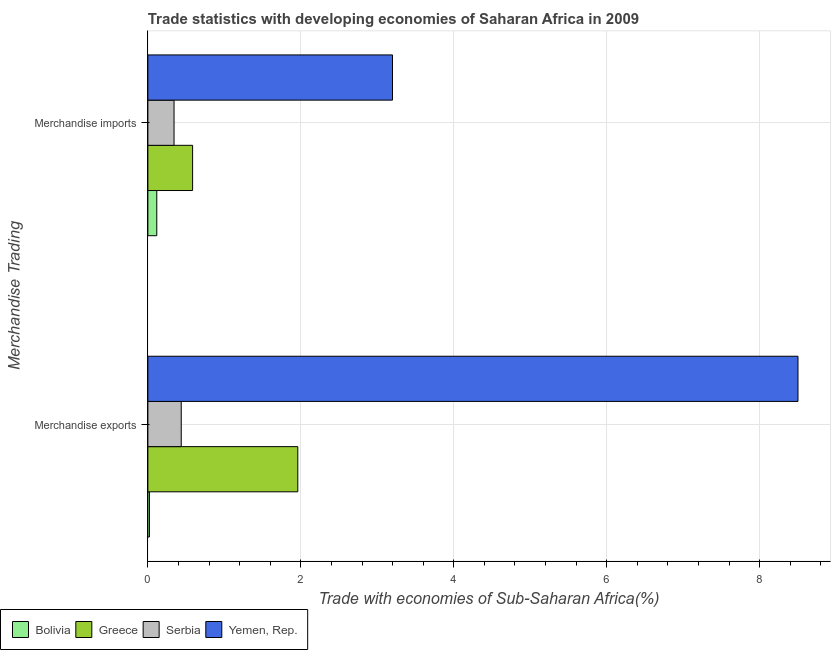How many different coloured bars are there?
Make the answer very short. 4. How many groups of bars are there?
Offer a very short reply. 2. Are the number of bars on each tick of the Y-axis equal?
Make the answer very short. Yes. What is the merchandise exports in Yemen, Rep.?
Provide a short and direct response. 8.5. Across all countries, what is the maximum merchandise imports?
Your answer should be compact. 3.2. Across all countries, what is the minimum merchandise exports?
Provide a succinct answer. 0.02. In which country was the merchandise imports maximum?
Your response must be concise. Yemen, Rep. In which country was the merchandise exports minimum?
Give a very brief answer. Bolivia. What is the total merchandise imports in the graph?
Offer a very short reply. 4.24. What is the difference between the merchandise exports in Greece and that in Bolivia?
Offer a very short reply. 1.94. What is the difference between the merchandise imports in Serbia and the merchandise exports in Bolivia?
Offer a terse response. 0.32. What is the average merchandise exports per country?
Your answer should be very brief. 2.73. What is the difference between the merchandise exports and merchandise imports in Serbia?
Give a very brief answer. 0.09. What is the ratio of the merchandise imports in Greece to that in Bolivia?
Offer a very short reply. 5.02. In how many countries, is the merchandise exports greater than the average merchandise exports taken over all countries?
Your answer should be compact. 1. What does the 2nd bar from the top in Merchandise exports represents?
Offer a terse response. Serbia. How many bars are there?
Your answer should be very brief. 8. Does the graph contain any zero values?
Make the answer very short. No. Does the graph contain grids?
Give a very brief answer. Yes. Where does the legend appear in the graph?
Offer a terse response. Bottom left. What is the title of the graph?
Give a very brief answer. Trade statistics with developing economies of Saharan Africa in 2009. What is the label or title of the X-axis?
Your response must be concise. Trade with economies of Sub-Saharan Africa(%). What is the label or title of the Y-axis?
Your response must be concise. Merchandise Trading. What is the Trade with economies of Sub-Saharan Africa(%) in Bolivia in Merchandise exports?
Your response must be concise. 0.02. What is the Trade with economies of Sub-Saharan Africa(%) in Greece in Merchandise exports?
Keep it short and to the point. 1.96. What is the Trade with economies of Sub-Saharan Africa(%) in Serbia in Merchandise exports?
Ensure brevity in your answer.  0.44. What is the Trade with economies of Sub-Saharan Africa(%) in Yemen, Rep. in Merchandise exports?
Offer a terse response. 8.5. What is the Trade with economies of Sub-Saharan Africa(%) of Bolivia in Merchandise imports?
Make the answer very short. 0.12. What is the Trade with economies of Sub-Saharan Africa(%) in Greece in Merchandise imports?
Your answer should be very brief. 0.58. What is the Trade with economies of Sub-Saharan Africa(%) in Serbia in Merchandise imports?
Your response must be concise. 0.34. What is the Trade with economies of Sub-Saharan Africa(%) of Yemen, Rep. in Merchandise imports?
Provide a short and direct response. 3.2. Across all Merchandise Trading, what is the maximum Trade with economies of Sub-Saharan Africa(%) in Bolivia?
Provide a succinct answer. 0.12. Across all Merchandise Trading, what is the maximum Trade with economies of Sub-Saharan Africa(%) in Greece?
Provide a succinct answer. 1.96. Across all Merchandise Trading, what is the maximum Trade with economies of Sub-Saharan Africa(%) of Serbia?
Provide a short and direct response. 0.44. Across all Merchandise Trading, what is the maximum Trade with economies of Sub-Saharan Africa(%) in Yemen, Rep.?
Keep it short and to the point. 8.5. Across all Merchandise Trading, what is the minimum Trade with economies of Sub-Saharan Africa(%) of Bolivia?
Make the answer very short. 0.02. Across all Merchandise Trading, what is the minimum Trade with economies of Sub-Saharan Africa(%) of Greece?
Provide a succinct answer. 0.58. Across all Merchandise Trading, what is the minimum Trade with economies of Sub-Saharan Africa(%) of Serbia?
Your answer should be compact. 0.34. Across all Merchandise Trading, what is the minimum Trade with economies of Sub-Saharan Africa(%) in Yemen, Rep.?
Your answer should be very brief. 3.2. What is the total Trade with economies of Sub-Saharan Africa(%) of Bolivia in the graph?
Keep it short and to the point. 0.14. What is the total Trade with economies of Sub-Saharan Africa(%) in Greece in the graph?
Offer a very short reply. 2.55. What is the total Trade with economies of Sub-Saharan Africa(%) of Serbia in the graph?
Provide a short and direct response. 0.78. What is the total Trade with economies of Sub-Saharan Africa(%) in Yemen, Rep. in the graph?
Your response must be concise. 11.7. What is the difference between the Trade with economies of Sub-Saharan Africa(%) of Bolivia in Merchandise exports and that in Merchandise imports?
Give a very brief answer. -0.1. What is the difference between the Trade with economies of Sub-Saharan Africa(%) of Greece in Merchandise exports and that in Merchandise imports?
Provide a short and direct response. 1.38. What is the difference between the Trade with economies of Sub-Saharan Africa(%) of Serbia in Merchandise exports and that in Merchandise imports?
Offer a terse response. 0.09. What is the difference between the Trade with economies of Sub-Saharan Africa(%) of Yemen, Rep. in Merchandise exports and that in Merchandise imports?
Give a very brief answer. 5.3. What is the difference between the Trade with economies of Sub-Saharan Africa(%) of Bolivia in Merchandise exports and the Trade with economies of Sub-Saharan Africa(%) of Greece in Merchandise imports?
Provide a succinct answer. -0.56. What is the difference between the Trade with economies of Sub-Saharan Africa(%) of Bolivia in Merchandise exports and the Trade with economies of Sub-Saharan Africa(%) of Serbia in Merchandise imports?
Your answer should be very brief. -0.32. What is the difference between the Trade with economies of Sub-Saharan Africa(%) in Bolivia in Merchandise exports and the Trade with economies of Sub-Saharan Africa(%) in Yemen, Rep. in Merchandise imports?
Provide a succinct answer. -3.18. What is the difference between the Trade with economies of Sub-Saharan Africa(%) of Greece in Merchandise exports and the Trade with economies of Sub-Saharan Africa(%) of Serbia in Merchandise imports?
Your answer should be very brief. 1.62. What is the difference between the Trade with economies of Sub-Saharan Africa(%) of Greece in Merchandise exports and the Trade with economies of Sub-Saharan Africa(%) of Yemen, Rep. in Merchandise imports?
Make the answer very short. -1.24. What is the difference between the Trade with economies of Sub-Saharan Africa(%) in Serbia in Merchandise exports and the Trade with economies of Sub-Saharan Africa(%) in Yemen, Rep. in Merchandise imports?
Give a very brief answer. -2.76. What is the average Trade with economies of Sub-Saharan Africa(%) of Bolivia per Merchandise Trading?
Keep it short and to the point. 0.07. What is the average Trade with economies of Sub-Saharan Africa(%) in Greece per Merchandise Trading?
Provide a short and direct response. 1.27. What is the average Trade with economies of Sub-Saharan Africa(%) in Serbia per Merchandise Trading?
Your answer should be compact. 0.39. What is the average Trade with economies of Sub-Saharan Africa(%) in Yemen, Rep. per Merchandise Trading?
Keep it short and to the point. 5.85. What is the difference between the Trade with economies of Sub-Saharan Africa(%) in Bolivia and Trade with economies of Sub-Saharan Africa(%) in Greece in Merchandise exports?
Provide a short and direct response. -1.94. What is the difference between the Trade with economies of Sub-Saharan Africa(%) of Bolivia and Trade with economies of Sub-Saharan Africa(%) of Serbia in Merchandise exports?
Keep it short and to the point. -0.42. What is the difference between the Trade with economies of Sub-Saharan Africa(%) in Bolivia and Trade with economies of Sub-Saharan Africa(%) in Yemen, Rep. in Merchandise exports?
Offer a very short reply. -8.48. What is the difference between the Trade with economies of Sub-Saharan Africa(%) in Greece and Trade with economies of Sub-Saharan Africa(%) in Serbia in Merchandise exports?
Provide a succinct answer. 1.52. What is the difference between the Trade with economies of Sub-Saharan Africa(%) in Greece and Trade with economies of Sub-Saharan Africa(%) in Yemen, Rep. in Merchandise exports?
Offer a terse response. -6.54. What is the difference between the Trade with economies of Sub-Saharan Africa(%) in Serbia and Trade with economies of Sub-Saharan Africa(%) in Yemen, Rep. in Merchandise exports?
Give a very brief answer. -8.06. What is the difference between the Trade with economies of Sub-Saharan Africa(%) of Bolivia and Trade with economies of Sub-Saharan Africa(%) of Greece in Merchandise imports?
Provide a succinct answer. -0.47. What is the difference between the Trade with economies of Sub-Saharan Africa(%) of Bolivia and Trade with economies of Sub-Saharan Africa(%) of Serbia in Merchandise imports?
Provide a short and direct response. -0.23. What is the difference between the Trade with economies of Sub-Saharan Africa(%) in Bolivia and Trade with economies of Sub-Saharan Africa(%) in Yemen, Rep. in Merchandise imports?
Make the answer very short. -3.08. What is the difference between the Trade with economies of Sub-Saharan Africa(%) in Greece and Trade with economies of Sub-Saharan Africa(%) in Serbia in Merchandise imports?
Your answer should be very brief. 0.24. What is the difference between the Trade with economies of Sub-Saharan Africa(%) in Greece and Trade with economies of Sub-Saharan Africa(%) in Yemen, Rep. in Merchandise imports?
Ensure brevity in your answer.  -2.61. What is the difference between the Trade with economies of Sub-Saharan Africa(%) in Serbia and Trade with economies of Sub-Saharan Africa(%) in Yemen, Rep. in Merchandise imports?
Offer a terse response. -2.86. What is the ratio of the Trade with economies of Sub-Saharan Africa(%) of Bolivia in Merchandise exports to that in Merchandise imports?
Provide a succinct answer. 0.17. What is the ratio of the Trade with economies of Sub-Saharan Africa(%) of Greece in Merchandise exports to that in Merchandise imports?
Provide a succinct answer. 3.35. What is the ratio of the Trade with economies of Sub-Saharan Africa(%) of Serbia in Merchandise exports to that in Merchandise imports?
Keep it short and to the point. 1.27. What is the ratio of the Trade with economies of Sub-Saharan Africa(%) in Yemen, Rep. in Merchandise exports to that in Merchandise imports?
Your answer should be very brief. 2.66. What is the difference between the highest and the second highest Trade with economies of Sub-Saharan Africa(%) in Bolivia?
Your answer should be compact. 0.1. What is the difference between the highest and the second highest Trade with economies of Sub-Saharan Africa(%) of Greece?
Ensure brevity in your answer.  1.38. What is the difference between the highest and the second highest Trade with economies of Sub-Saharan Africa(%) in Serbia?
Make the answer very short. 0.09. What is the difference between the highest and the second highest Trade with economies of Sub-Saharan Africa(%) of Yemen, Rep.?
Ensure brevity in your answer.  5.3. What is the difference between the highest and the lowest Trade with economies of Sub-Saharan Africa(%) in Bolivia?
Offer a terse response. 0.1. What is the difference between the highest and the lowest Trade with economies of Sub-Saharan Africa(%) of Greece?
Offer a very short reply. 1.38. What is the difference between the highest and the lowest Trade with economies of Sub-Saharan Africa(%) in Serbia?
Give a very brief answer. 0.09. What is the difference between the highest and the lowest Trade with economies of Sub-Saharan Africa(%) of Yemen, Rep.?
Ensure brevity in your answer.  5.3. 